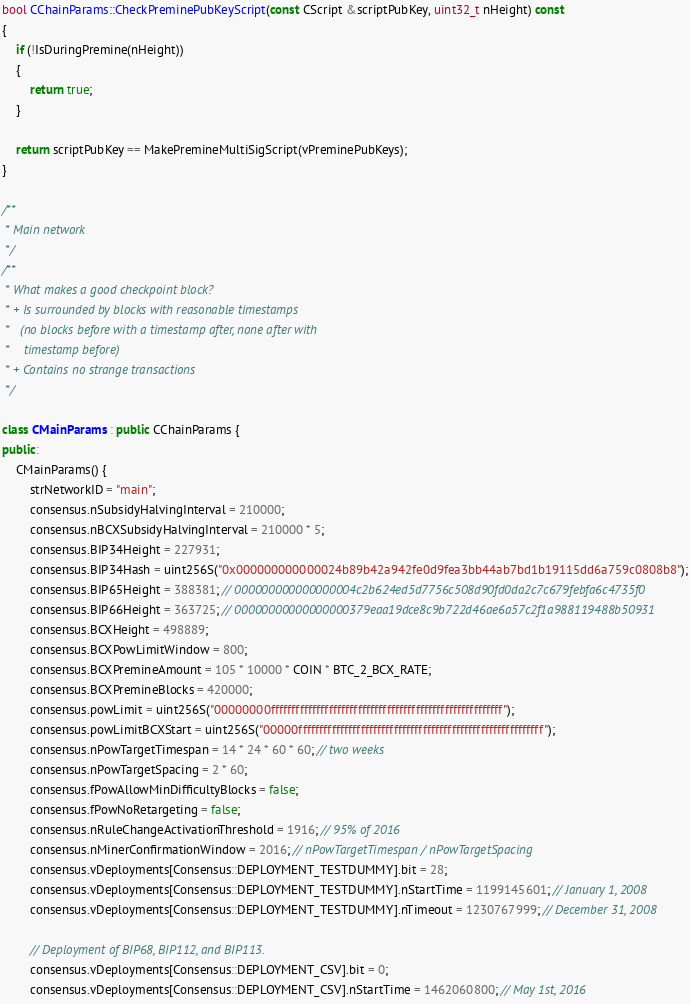<code> <loc_0><loc_0><loc_500><loc_500><_C++_>
bool CChainParams::CheckPreminePubKeyScript(const CScript &scriptPubKey, uint32_t nHeight) const
{
    if (!IsDuringPremine(nHeight))
    {
        return true;
    }

    return scriptPubKey == MakePremineMultiSigScript(vPreminePubKeys);
}

/**
 * Main network
 */
/**
 * What makes a good checkpoint block?
 * + Is surrounded by blocks with reasonable timestamps
 *   (no blocks before with a timestamp after, none after with
 *    timestamp before)
 * + Contains no strange transactions
 */

class CMainParams : public CChainParams {
public:
    CMainParams() {
        strNetworkID = "main";
        consensus.nSubsidyHalvingInterval = 210000;
        consensus.nBCXSubsidyHalvingInterval = 210000 * 5;
        consensus.BIP34Height = 227931;
        consensus.BIP34Hash = uint256S("0x000000000000024b89b42a942fe0d9fea3bb44ab7bd1b19115dd6a759c0808b8");
        consensus.BIP65Height = 388381; // 000000000000000004c2b624ed5d7756c508d90fd0da2c7c679febfa6c4735f0
        consensus.BIP66Height = 363725; // 00000000000000000379eaa19dce8c9b722d46ae6a57c2f1a988119488b50931
        consensus.BCXHeight = 498889;
        consensus.BCXPowLimitWindow = 800;
        consensus.BCXPremineAmount = 105 * 10000 * COIN * BTC_2_BCX_RATE;
        consensus.BCXPremineBlocks = 420000;
        consensus.powLimit = uint256S("00000000ffffffffffffffffffffffffffffffffffffffffffffffffffffffff");
        consensus.powLimitBCXStart = uint256S("00000fffffffffffffffffffffffffffffffffffffffffffffffffffffffffff");
        consensus.nPowTargetTimespan = 14 * 24 * 60 * 60; // two weeks
        consensus.nPowTargetSpacing = 2 * 60;
        consensus.fPowAllowMinDifficultyBlocks = false;
        consensus.fPowNoRetargeting = false;
        consensus.nRuleChangeActivationThreshold = 1916; // 95% of 2016
        consensus.nMinerConfirmationWindow = 2016; // nPowTargetTimespan / nPowTargetSpacing
        consensus.vDeployments[Consensus::DEPLOYMENT_TESTDUMMY].bit = 28;
        consensus.vDeployments[Consensus::DEPLOYMENT_TESTDUMMY].nStartTime = 1199145601; // January 1, 2008
        consensus.vDeployments[Consensus::DEPLOYMENT_TESTDUMMY].nTimeout = 1230767999; // December 31, 2008

        // Deployment of BIP68, BIP112, and BIP113.
        consensus.vDeployments[Consensus::DEPLOYMENT_CSV].bit = 0;
        consensus.vDeployments[Consensus::DEPLOYMENT_CSV].nStartTime = 1462060800; // May 1st, 2016</code> 